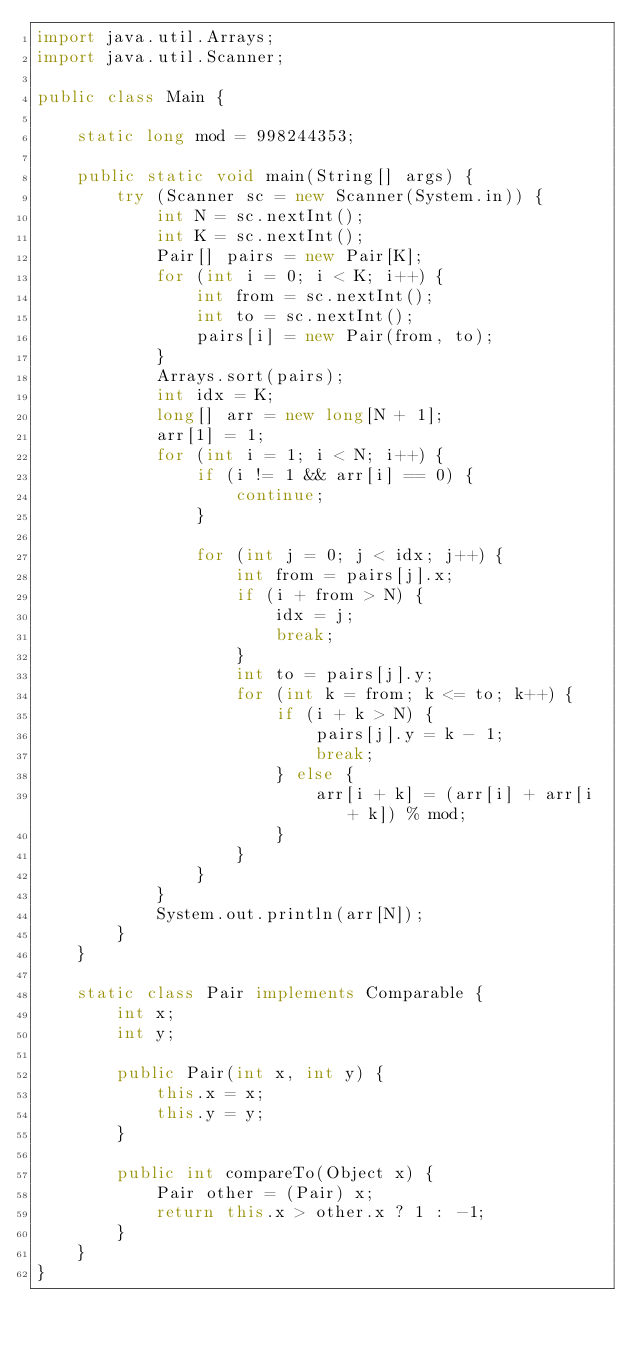Convert code to text. <code><loc_0><loc_0><loc_500><loc_500><_Java_>import java.util.Arrays;
import java.util.Scanner;

public class Main {

	static long mod = 998244353;

	public static void main(String[] args) {
		try (Scanner sc = new Scanner(System.in)) {
			int N = sc.nextInt();
			int K = sc.nextInt();
			Pair[] pairs = new Pair[K];
			for (int i = 0; i < K; i++) {
				int from = sc.nextInt();
				int to = sc.nextInt();
				pairs[i] = new Pair(from, to);
			}
			Arrays.sort(pairs);
			int idx = K;
			long[] arr = new long[N + 1];
			arr[1] = 1;
			for (int i = 1; i < N; i++) {
				if (i != 1 && arr[i] == 0) {
					continue;
				}

				for (int j = 0; j < idx; j++) {
					int from = pairs[j].x;
					if (i + from > N) {
						idx = j;
						break;
					}
					int to = pairs[j].y;
					for (int k = from; k <= to; k++) {
						if (i + k > N) {
							pairs[j].y = k - 1;
							break;
						} else {
							arr[i + k] = (arr[i] + arr[i + k]) % mod;
						}
					}
				}
			}
			System.out.println(arr[N]);
		}
	}

	static class Pair implements Comparable {
		int x;
		int y;

		public Pair(int x, int y) {
			this.x = x;
			this.y = y;
		}

		public int compareTo(Object x) {
			Pair other = (Pair) x;
			return this.x > other.x ? 1 : -1;
		}
	}
}</code> 